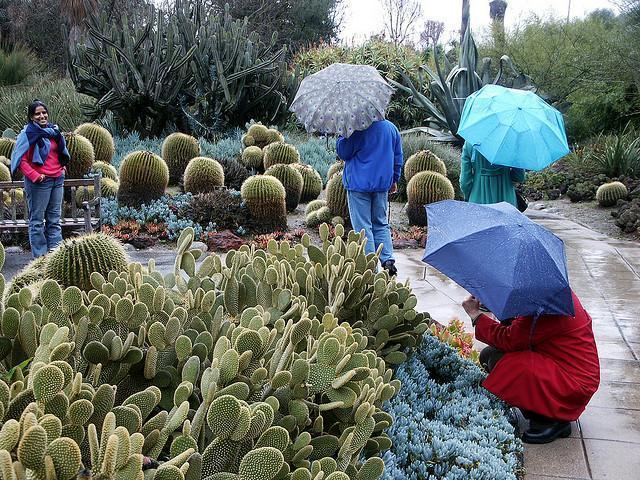How many umbrellas are visible?
Give a very brief answer. 3. How many people are there?
Give a very brief answer. 4. 